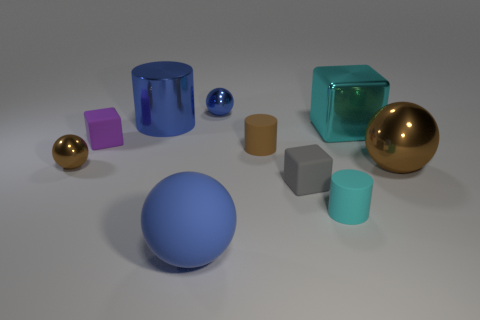Subtract all large blue balls. How many balls are left? 3 Subtract all cubes. How many objects are left? 7 Subtract 1 cubes. How many cubes are left? 2 Add 9 small purple things. How many small purple things are left? 10 Add 2 big metal blocks. How many big metal blocks exist? 3 Subtract 0 yellow blocks. How many objects are left? 10 Subtract all gray cylinders. Subtract all purple spheres. How many cylinders are left? 3 Subtract all purple cylinders. How many yellow blocks are left? 0 Subtract all large purple metallic balls. Subtract all cyan matte cylinders. How many objects are left? 9 